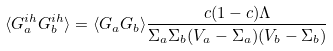<formula> <loc_0><loc_0><loc_500><loc_500>\langle G _ { a } ^ { i h } G _ { b } ^ { i h } \rangle = \langle G _ { a } G _ { b } \rangle \frac { c ( 1 - c ) \Lambda } { \Sigma _ { a } \Sigma _ { b } ( V _ { a } - \Sigma _ { a } ) ( V _ { b } - \Sigma _ { b } ) }</formula> 